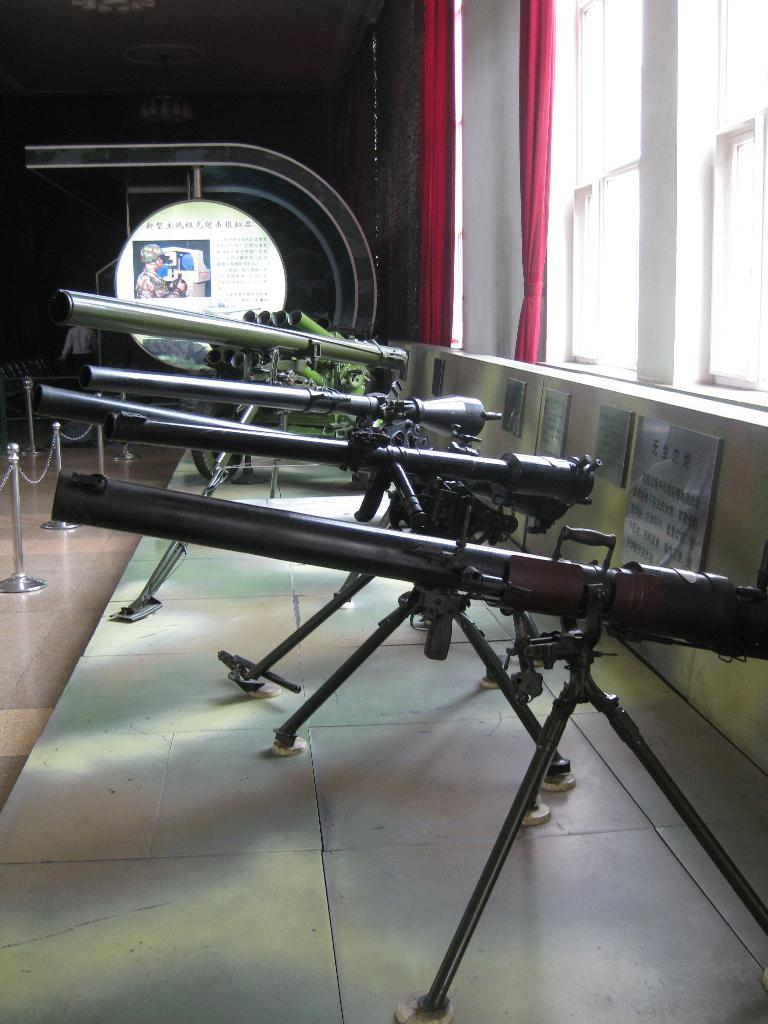What type of weapons are on display in the image? There are rifles on stands in the image. How are the rifles positioned in the image? The rifles are placed on stands, which are on a surface. What other objects can be seen in the image? There are boards and metal poles with chains present in the image. What type of window treatment is visible in the image? Windows with curtains are visible in the image. What type of structure is present in the image? There is a wall in the image. How does the mist affect the visibility of the rifles in the image? There is no mist present in the image, so it does not affect the visibility of the rifles. 